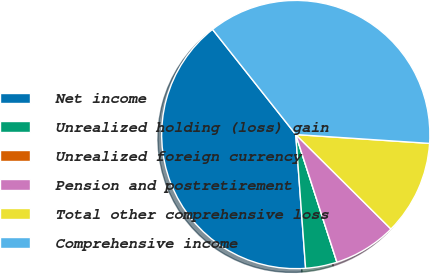Convert chart. <chart><loc_0><loc_0><loc_500><loc_500><pie_chart><fcel>Net income<fcel>Unrealized holding (loss) gain<fcel>Unrealized foreign currency<fcel>Pension and postretirement<fcel>Total other comprehensive loss<fcel>Comprehensive income<nl><fcel>40.51%<fcel>3.8%<fcel>0.0%<fcel>7.59%<fcel>11.39%<fcel>36.71%<nl></chart> 